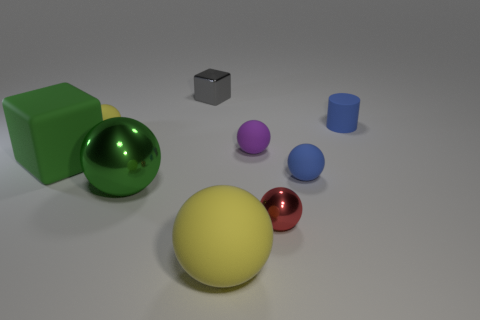Subtract 1 balls. How many balls are left? 5 Subtract all blue spheres. How many spheres are left? 5 Subtract all large matte spheres. How many spheres are left? 5 Subtract all purple spheres. Subtract all purple cylinders. How many spheres are left? 5 Add 1 green metallic things. How many objects exist? 10 Subtract all cylinders. How many objects are left? 8 Subtract 0 red blocks. How many objects are left? 9 Subtract all big brown metal cylinders. Subtract all yellow rubber spheres. How many objects are left? 7 Add 3 large things. How many large things are left? 6 Add 6 yellow spheres. How many yellow spheres exist? 8 